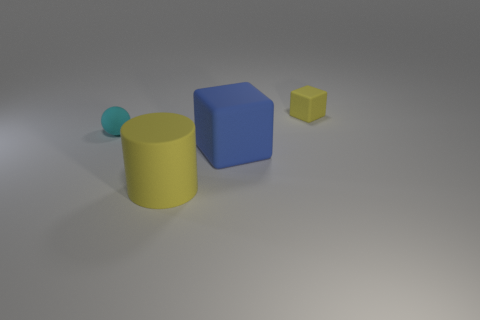There is a tiny block that is the same color as the large cylinder; what is it made of?
Your response must be concise. Rubber. What number of tiny balls are the same color as the cylinder?
Your answer should be very brief. 0. Are the cyan ball and the thing that is on the right side of the big matte block made of the same material?
Provide a succinct answer. Yes. Are there more tiny yellow things behind the yellow cube than large rubber cylinders?
Provide a succinct answer. No. Is there anything else that is the same size as the matte cylinder?
Ensure brevity in your answer.  Yes. There is a small cube; is its color the same as the rubber block in front of the cyan rubber object?
Offer a very short reply. No. Is the number of matte cubes that are in front of the large cylinder the same as the number of large rubber cylinders behind the small cyan matte thing?
Ensure brevity in your answer.  Yes. There is a yellow object behind the large blue cube; what is it made of?
Ensure brevity in your answer.  Rubber. How many objects are either things that are behind the cyan object or shiny balls?
Your answer should be very brief. 1. What number of other things are there of the same shape as the big blue matte thing?
Make the answer very short. 1. 